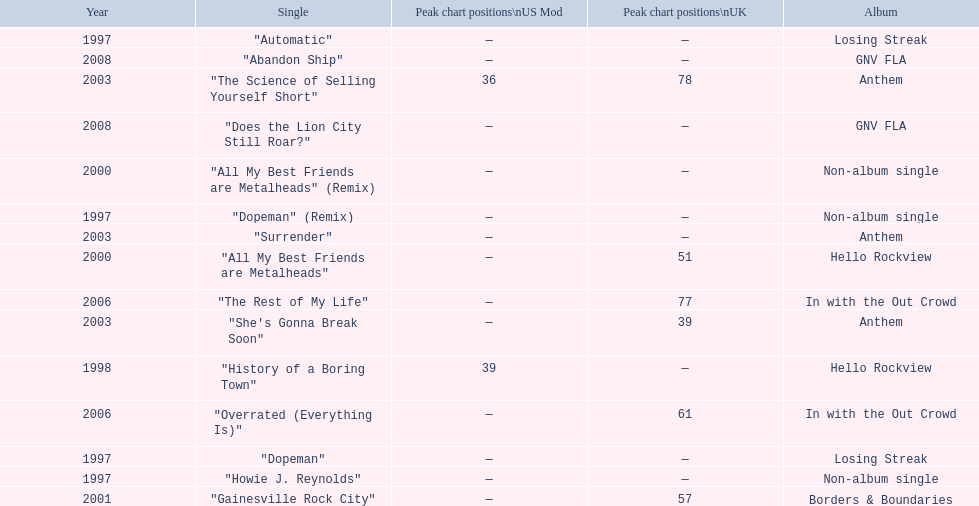What was the first single to earn a chart position? "History of a Boring Town". 